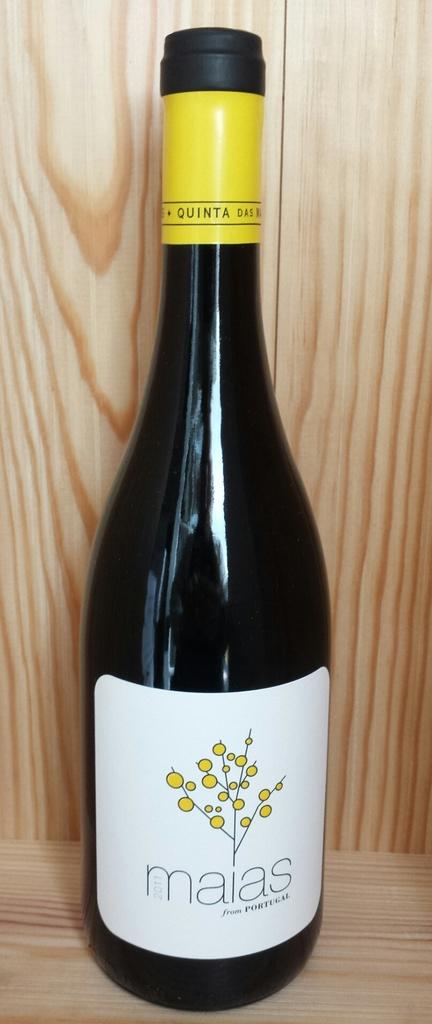What is the name of this brand of wine?
Make the answer very short. Maias. Who made this brand of wine?
Provide a short and direct response. Maias. 